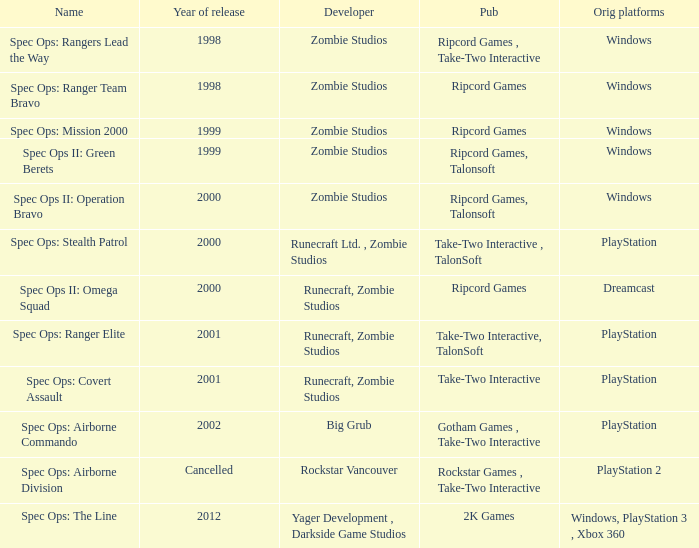Help me parse the entirety of this table. {'header': ['Name', 'Year of release', 'Developer', 'Pub', 'Orig platforms'], 'rows': [['Spec Ops: Rangers Lead the Way', '1998', 'Zombie Studios', 'Ripcord Games , Take-Two Interactive', 'Windows'], ['Spec Ops: Ranger Team Bravo', '1998', 'Zombie Studios', 'Ripcord Games', 'Windows'], ['Spec Ops: Mission 2000', '1999', 'Zombie Studios', 'Ripcord Games', 'Windows'], ['Spec Ops II: Green Berets', '1999', 'Zombie Studios', 'Ripcord Games, Talonsoft', 'Windows'], ['Spec Ops II: Operation Bravo', '2000', 'Zombie Studios', 'Ripcord Games, Talonsoft', 'Windows'], ['Spec Ops: Stealth Patrol', '2000', 'Runecraft Ltd. , Zombie Studios', 'Take-Two Interactive , TalonSoft', 'PlayStation'], ['Spec Ops II: Omega Squad', '2000', 'Runecraft, Zombie Studios', 'Ripcord Games', 'Dreamcast'], ['Spec Ops: Ranger Elite', '2001', 'Runecraft, Zombie Studios', 'Take-Two Interactive, TalonSoft', 'PlayStation'], ['Spec Ops: Covert Assault', '2001', 'Runecraft, Zombie Studios', 'Take-Two Interactive', 'PlayStation'], ['Spec Ops: Airborne Commando', '2002', 'Big Grub', 'Gotham Games , Take-Two Interactive', 'PlayStation'], ['Spec Ops: Airborne Division', 'Cancelled', 'Rockstar Vancouver', 'Rockstar Games , Take-Two Interactive', 'PlayStation 2'], ['Spec Ops: The Line', '2012', 'Yager Development , Darkside Game Studios', '2K Games', 'Windows, PlayStation 3 , Xbox 360']]} Who is the publisher behind spec ops: stealth patrol? Take-Two Interactive , TalonSoft. 